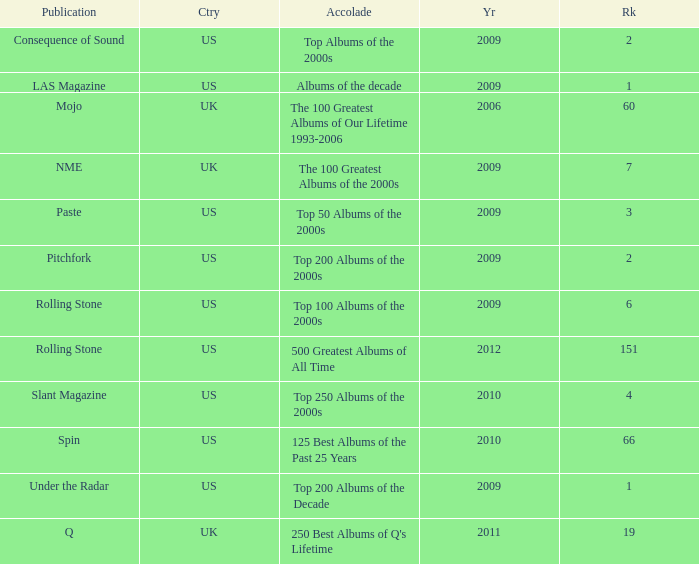What was the lowest rank after 2009 with an accolade of 125 best albums of the past 25 years? 66.0. 